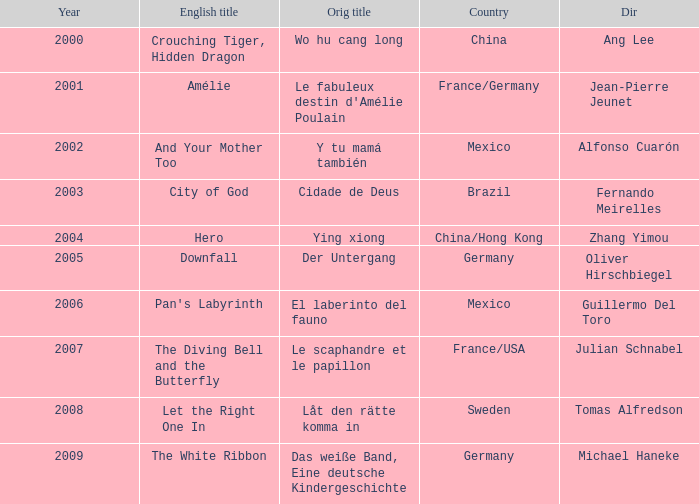Name the title of jean-pierre jeunet Amélie. 